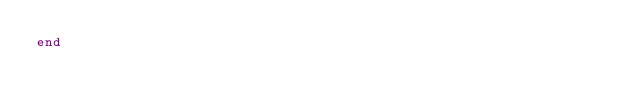<code> <loc_0><loc_0><loc_500><loc_500><_Ruby_>end
</code> 